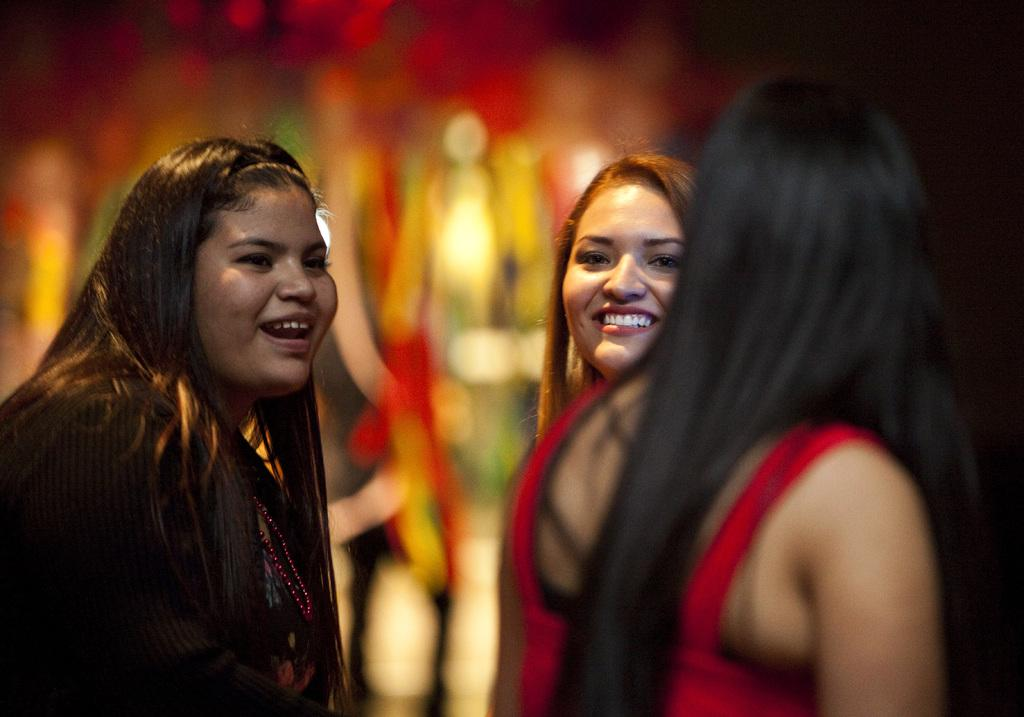How many women are visible in the image? There are two women visible in the image, one wearing a black dress and the other wearing a red dress. Can you describe the other woman in the image? There is another woman in the background of the image. What can be seen in the background of the image? There are blurry objects in the background of the image. What type of fingerprint can be seen on the red dress in the image? There is no fingerprint visible on the red dress in the image. Is there any snow present in the image? There is no snow present in the image. 